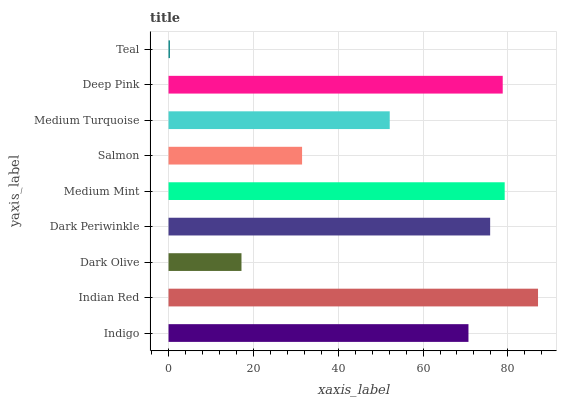Is Teal the minimum?
Answer yes or no. Yes. Is Indian Red the maximum?
Answer yes or no. Yes. Is Dark Olive the minimum?
Answer yes or no. No. Is Dark Olive the maximum?
Answer yes or no. No. Is Indian Red greater than Dark Olive?
Answer yes or no. Yes. Is Dark Olive less than Indian Red?
Answer yes or no. Yes. Is Dark Olive greater than Indian Red?
Answer yes or no. No. Is Indian Red less than Dark Olive?
Answer yes or no. No. Is Indigo the high median?
Answer yes or no. Yes. Is Indigo the low median?
Answer yes or no. Yes. Is Medium Turquoise the high median?
Answer yes or no. No. Is Teal the low median?
Answer yes or no. No. 